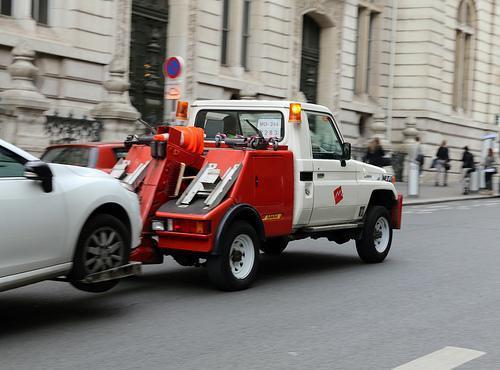How many cars are being towed?
Give a very brief answer. 1. 